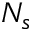<formula> <loc_0><loc_0><loc_500><loc_500>N _ { s }</formula> 